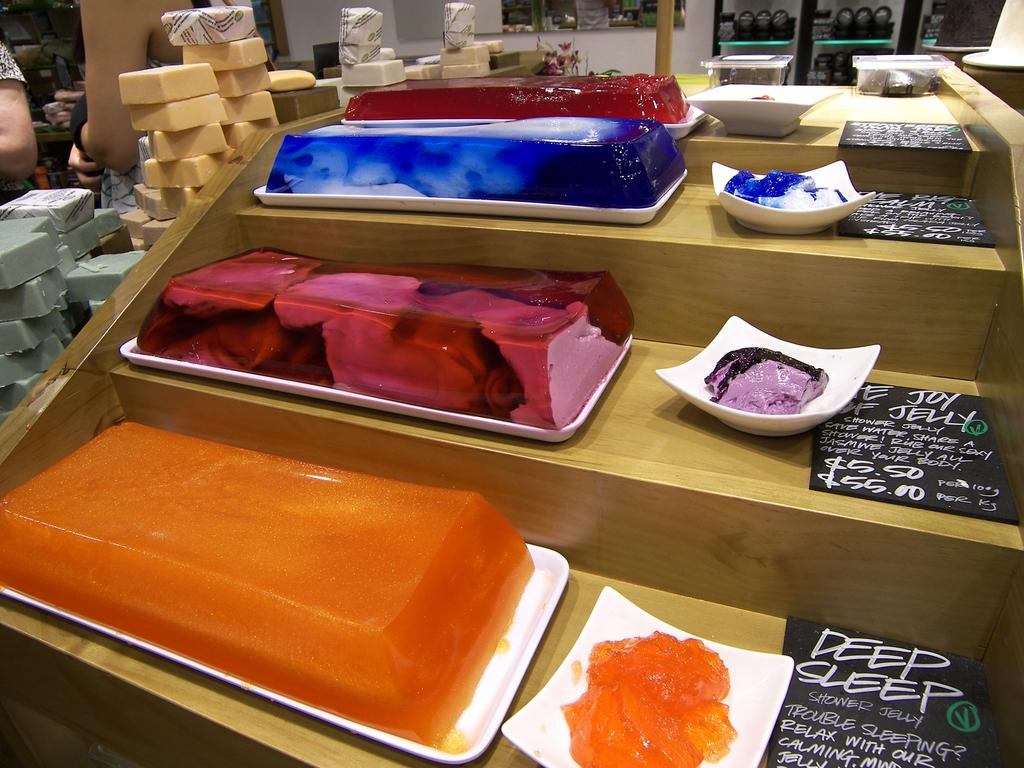What type of desserts can be seen in the image? There are cakes and jellies in the image. How are the cakes and jellies arranged in the image? The cakes and jellies are on plates in the image. What other type of sweet treat is visible in the image? There are candies to the left in the image. What can be seen to the right in the image? There are boards on a desk to the right in the image. What material is the desk made of? The desk is made of wood. How many clams are present on the desk in the image? There are no clams present on the desk in the image. What type of teeth can be seen in the image? There are no teeth visible in the image. 